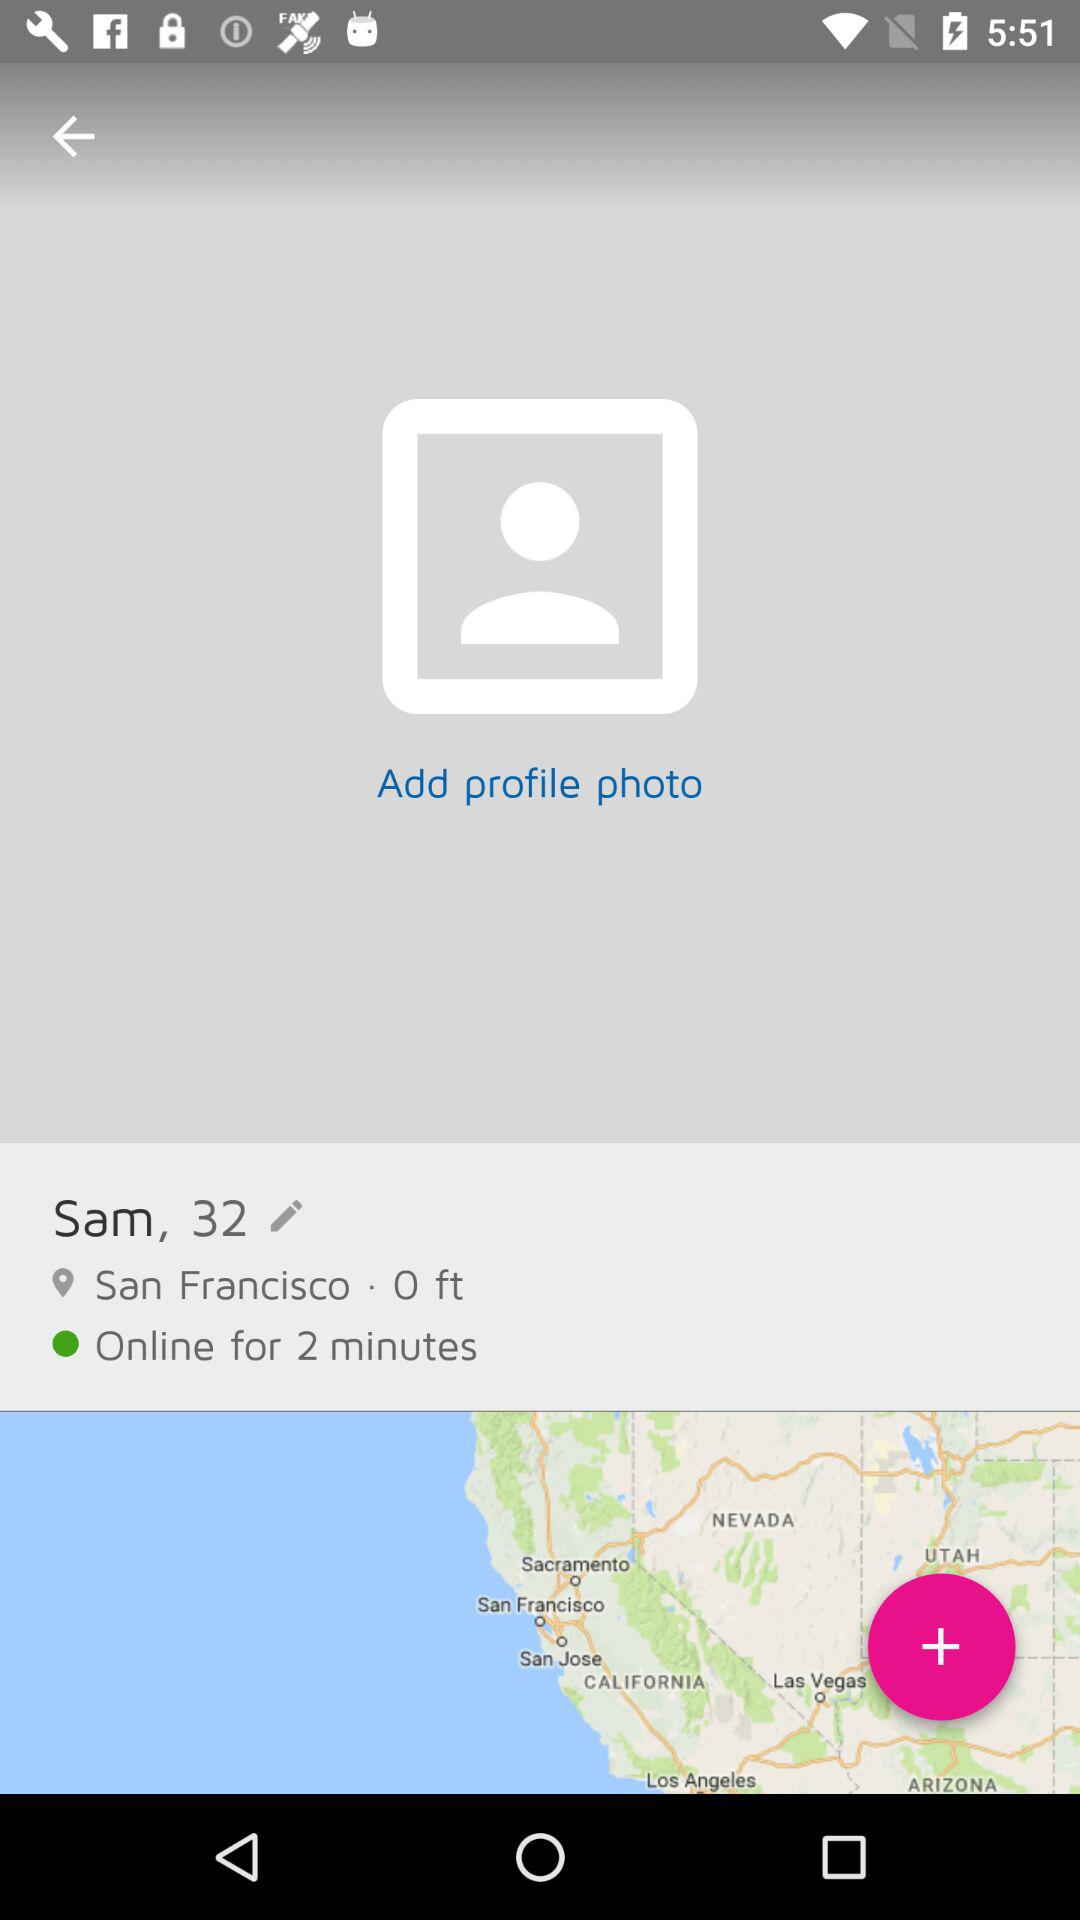How long has Sam been online?
Answer the question using a single word or phrase. 2 minutes 